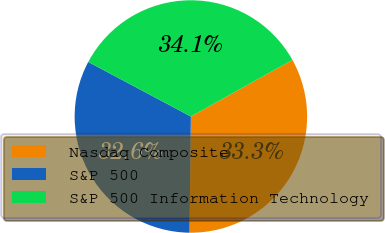Convert chart. <chart><loc_0><loc_0><loc_500><loc_500><pie_chart><fcel>Nasdaq Composite<fcel>S&P 500<fcel>S&P 500 Information Technology<nl><fcel>33.28%<fcel>32.59%<fcel>34.13%<nl></chart> 